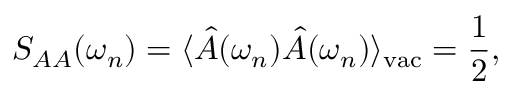Convert formula to latex. <formula><loc_0><loc_0><loc_500><loc_500>S _ { A A } ( \omega _ { n } ) = \langle \hat { A } ( \omega _ { n } ) \hat { A } ( \omega _ { n } ) \rangle _ { v a c } = \frac { 1 } { 2 } ,</formula> 